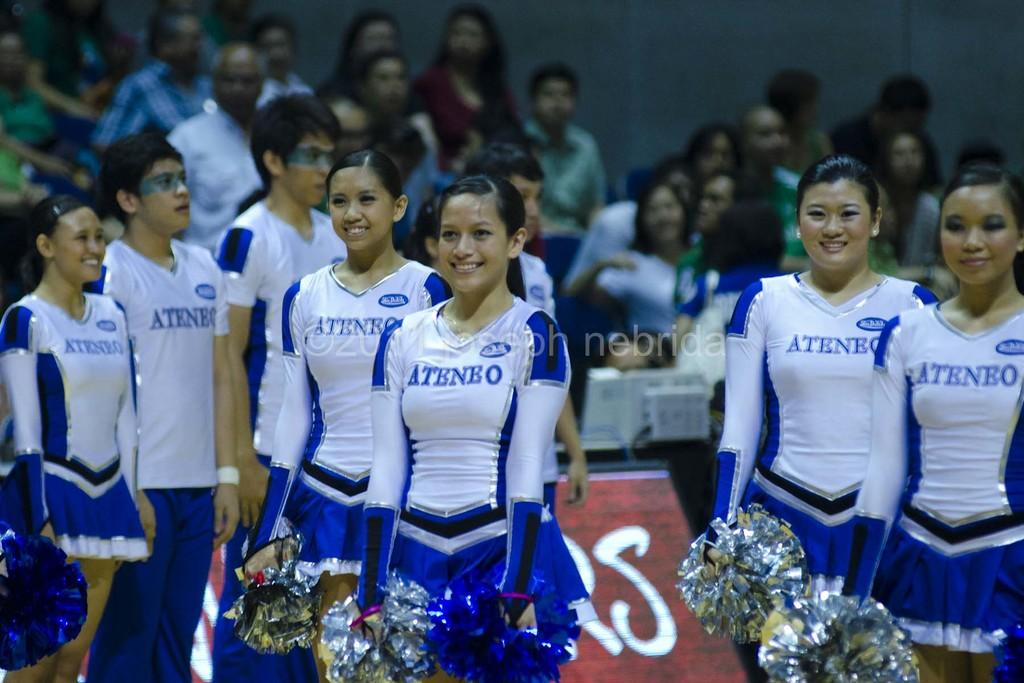<image>
Present a compact description of the photo's key features. A team of cheerleaders are about to perform wearing white and blue and a ATHENO logo 